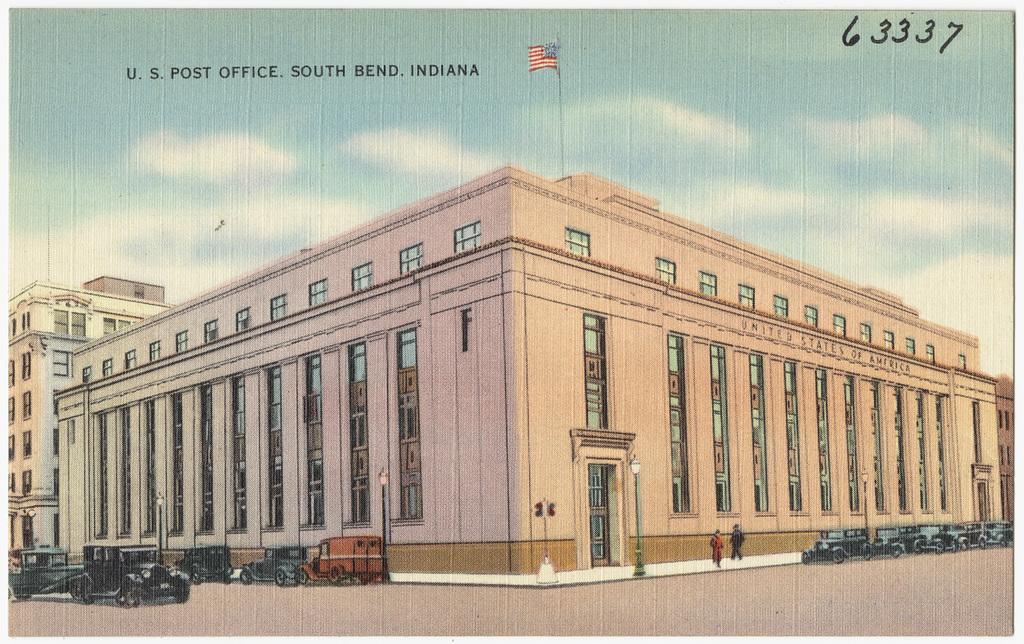How would you summarize this image in a sentence or two? In the image we can see some vehicles and buildings, on the building there is a pole and flag. Behind the building there are some clouds and sky. 